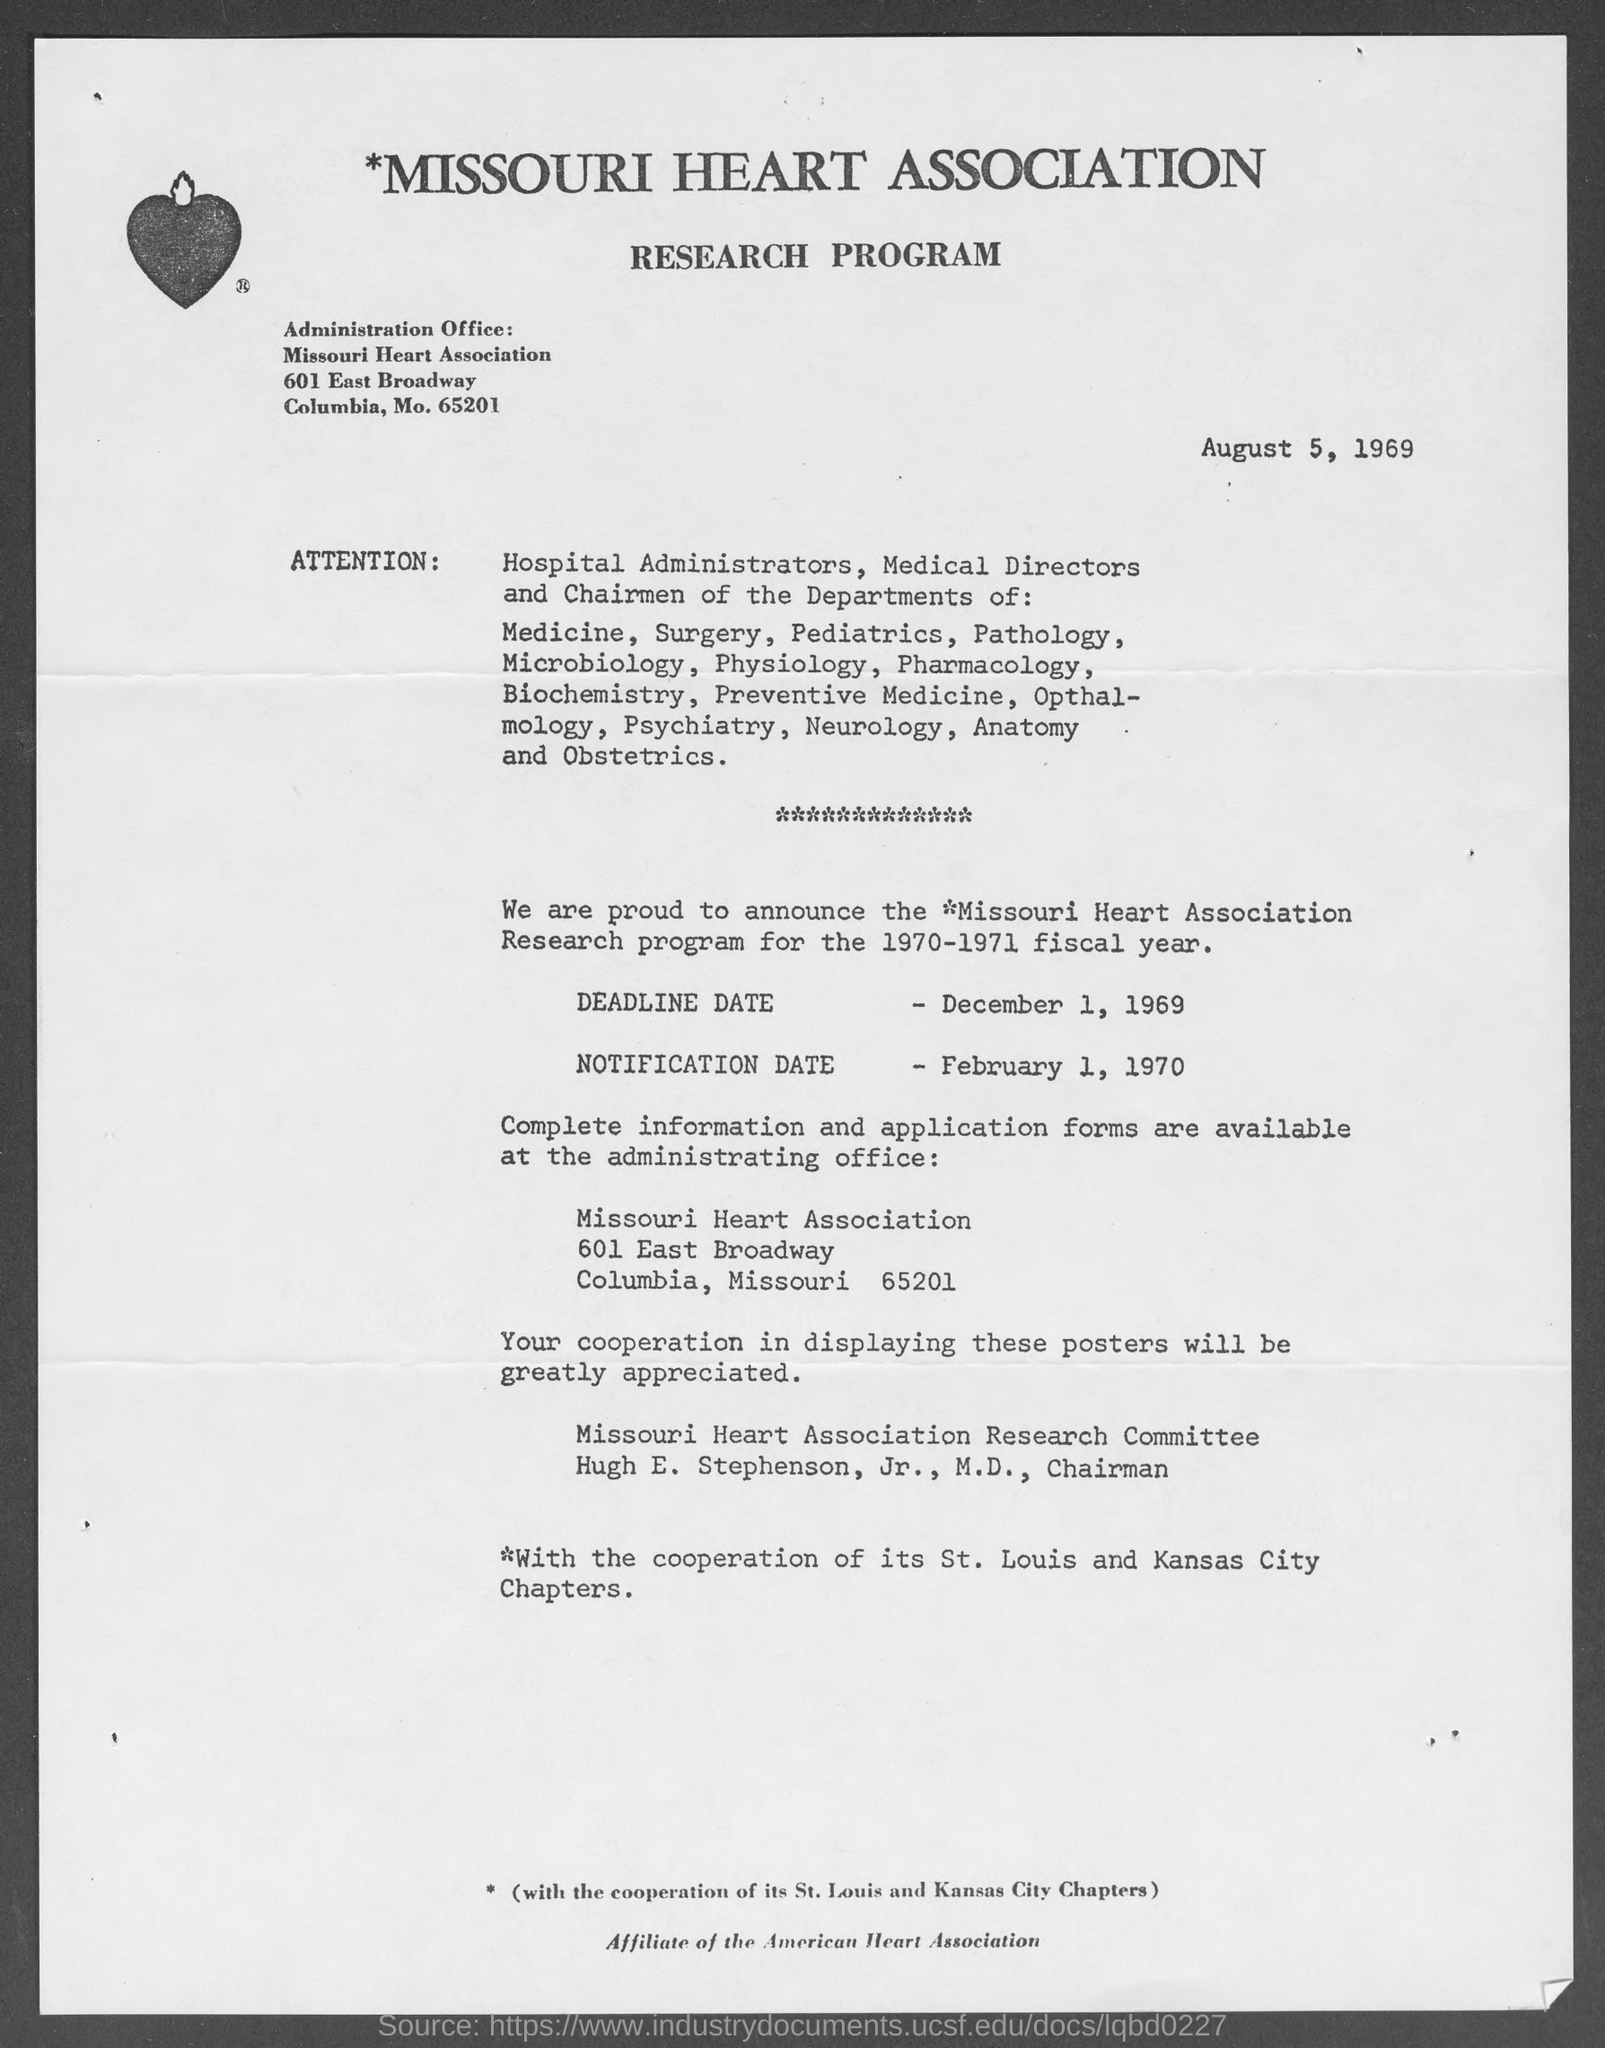What is the name of heart association ?
Make the answer very short. *Missouri. What is the position of hugh e. stepson, jr., m.d. ?
Provide a succinct answer. M.D., chairman. What is deadline date for research program for 1970-1971?
Your response must be concise. December 1, 1969. What is the notification date for research program for 1970-71?
Your response must be concise. February 1, 1970. 